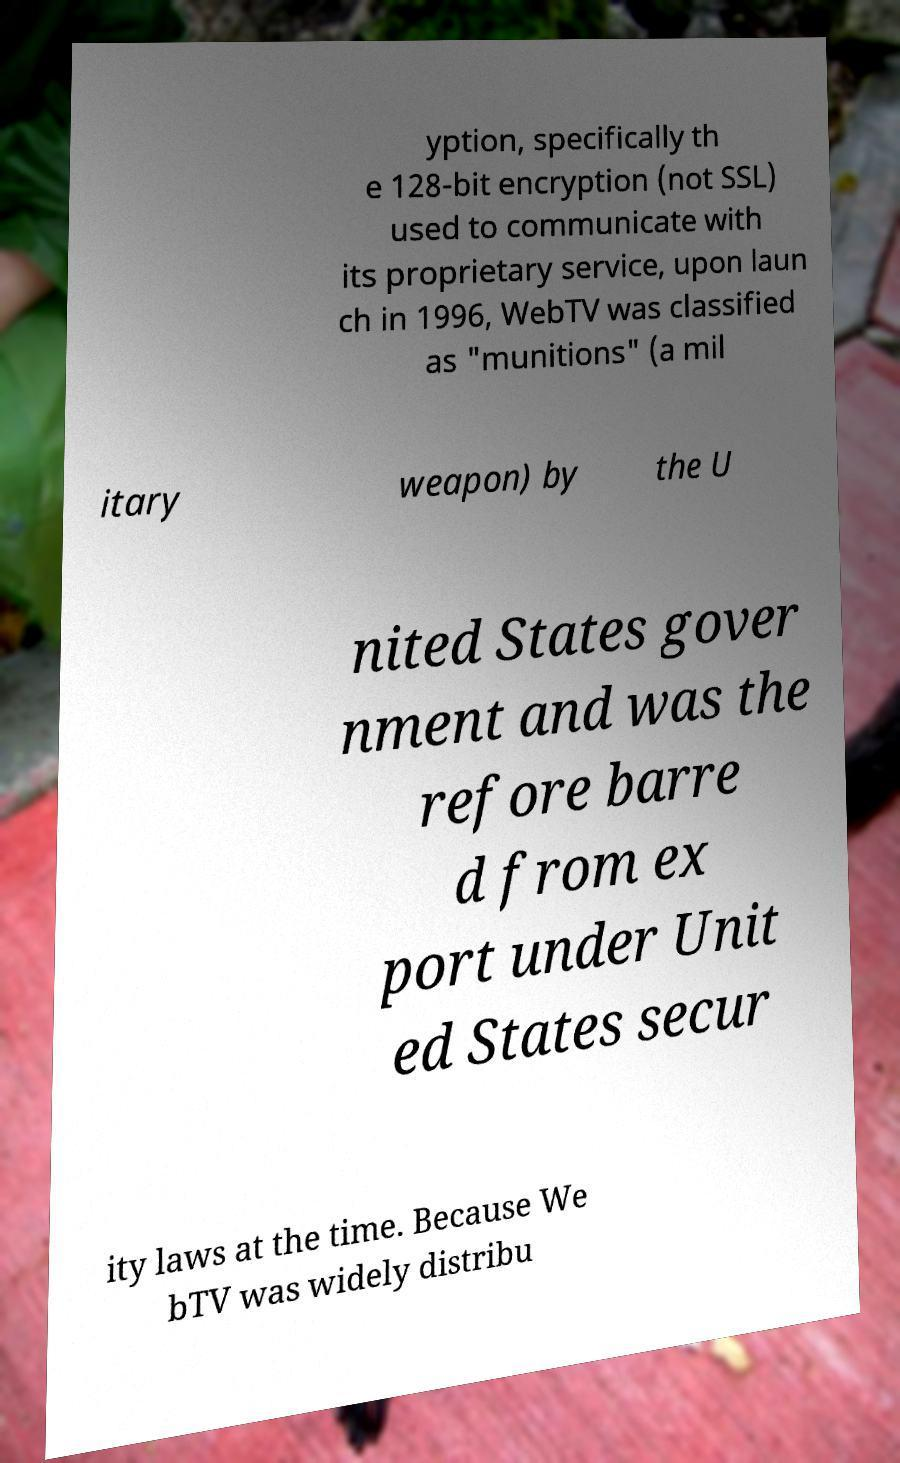There's text embedded in this image that I need extracted. Can you transcribe it verbatim? yption, specifically th e 128-bit encryption (not SSL) used to communicate with its proprietary service, upon laun ch in 1996, WebTV was classified as "munitions" (a mil itary weapon) by the U nited States gover nment and was the refore barre d from ex port under Unit ed States secur ity laws at the time. Because We bTV was widely distribu 